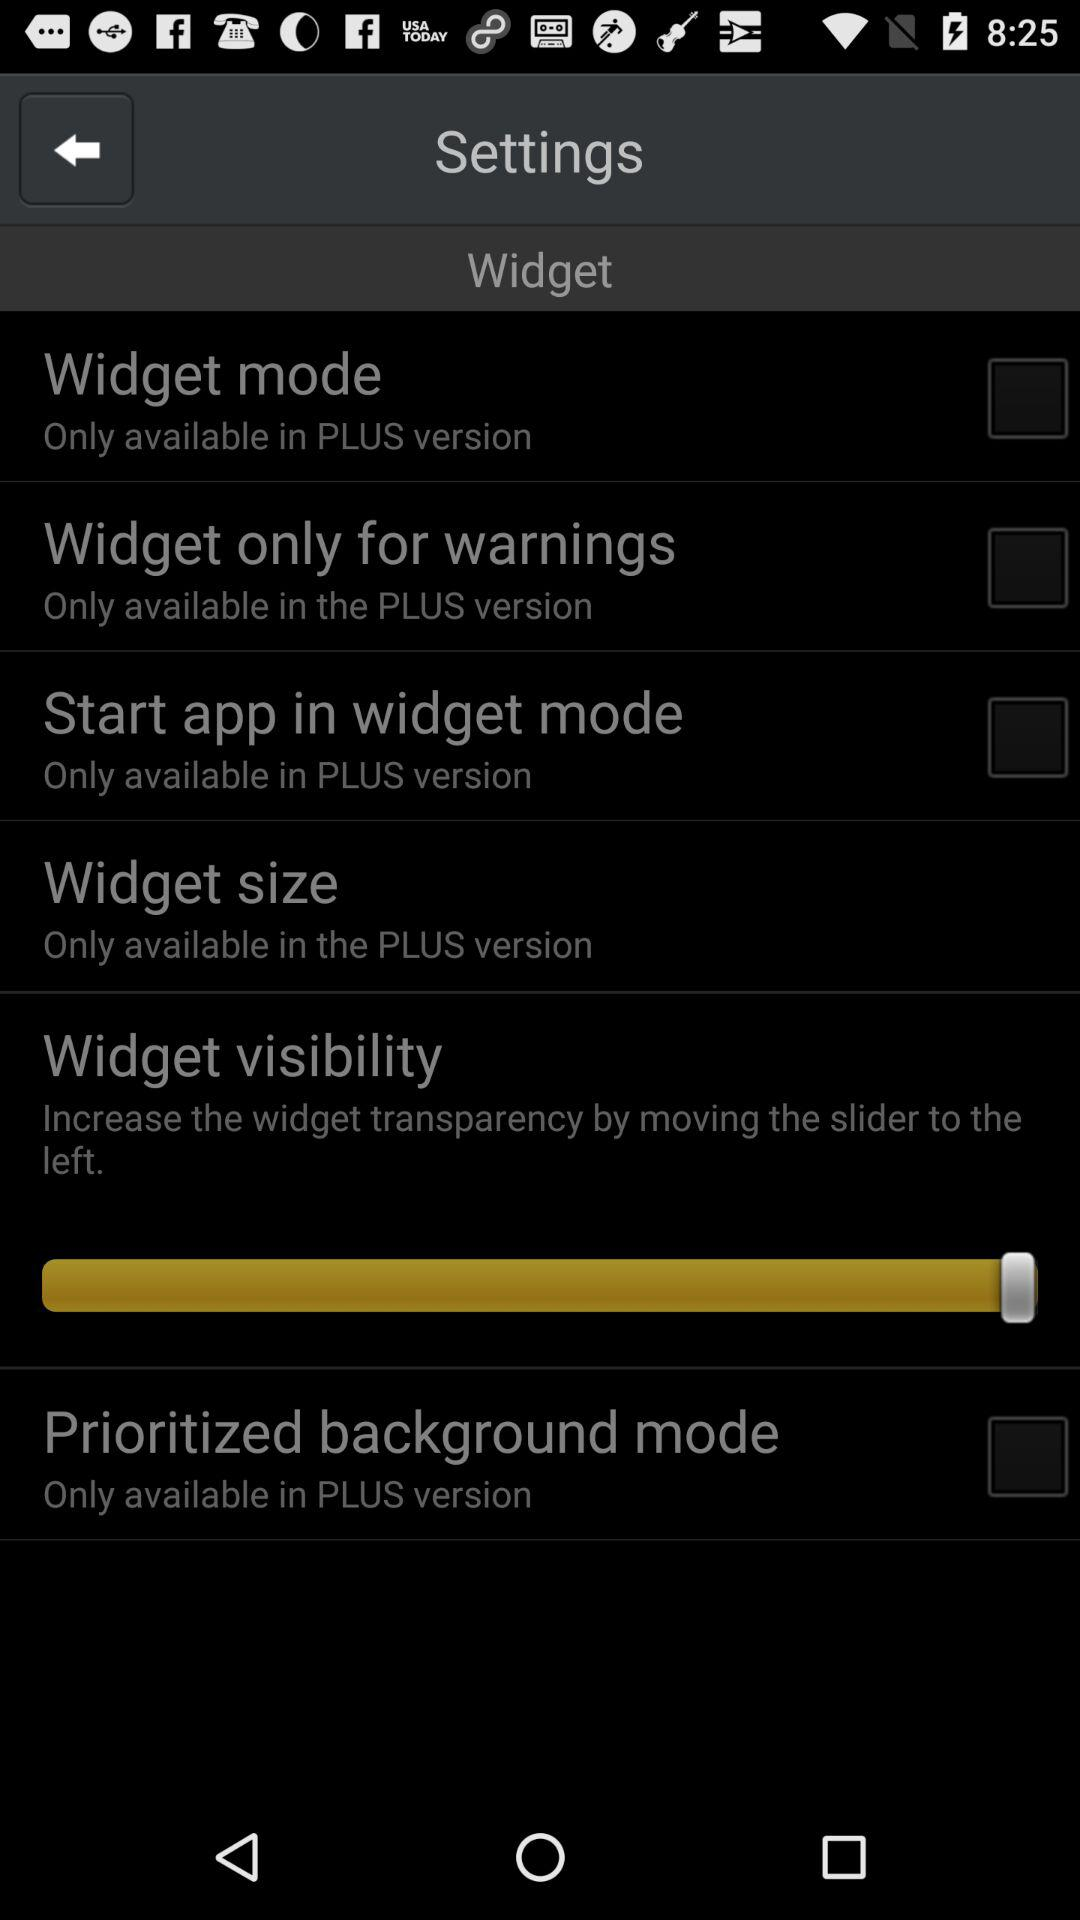In which version is the prioritized background mode only available? The prioritized background mode is only available in the PLUS version. 